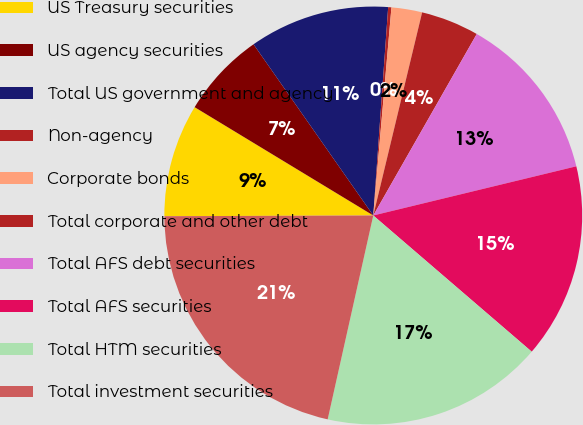Convert chart to OTSL. <chart><loc_0><loc_0><loc_500><loc_500><pie_chart><fcel>US Treasury securities<fcel>US agency securities<fcel>Total US government and agency<fcel>Non-agency<fcel>Corporate bonds<fcel>Total corporate and other debt<fcel>Total AFS debt securities<fcel>Total AFS securities<fcel>Total HTM securities<fcel>Total investment securities<nl><fcel>8.73%<fcel>6.61%<fcel>10.85%<fcel>0.25%<fcel>2.37%<fcel>4.49%<fcel>12.97%<fcel>15.08%<fcel>17.2%<fcel>21.44%<nl></chart> 